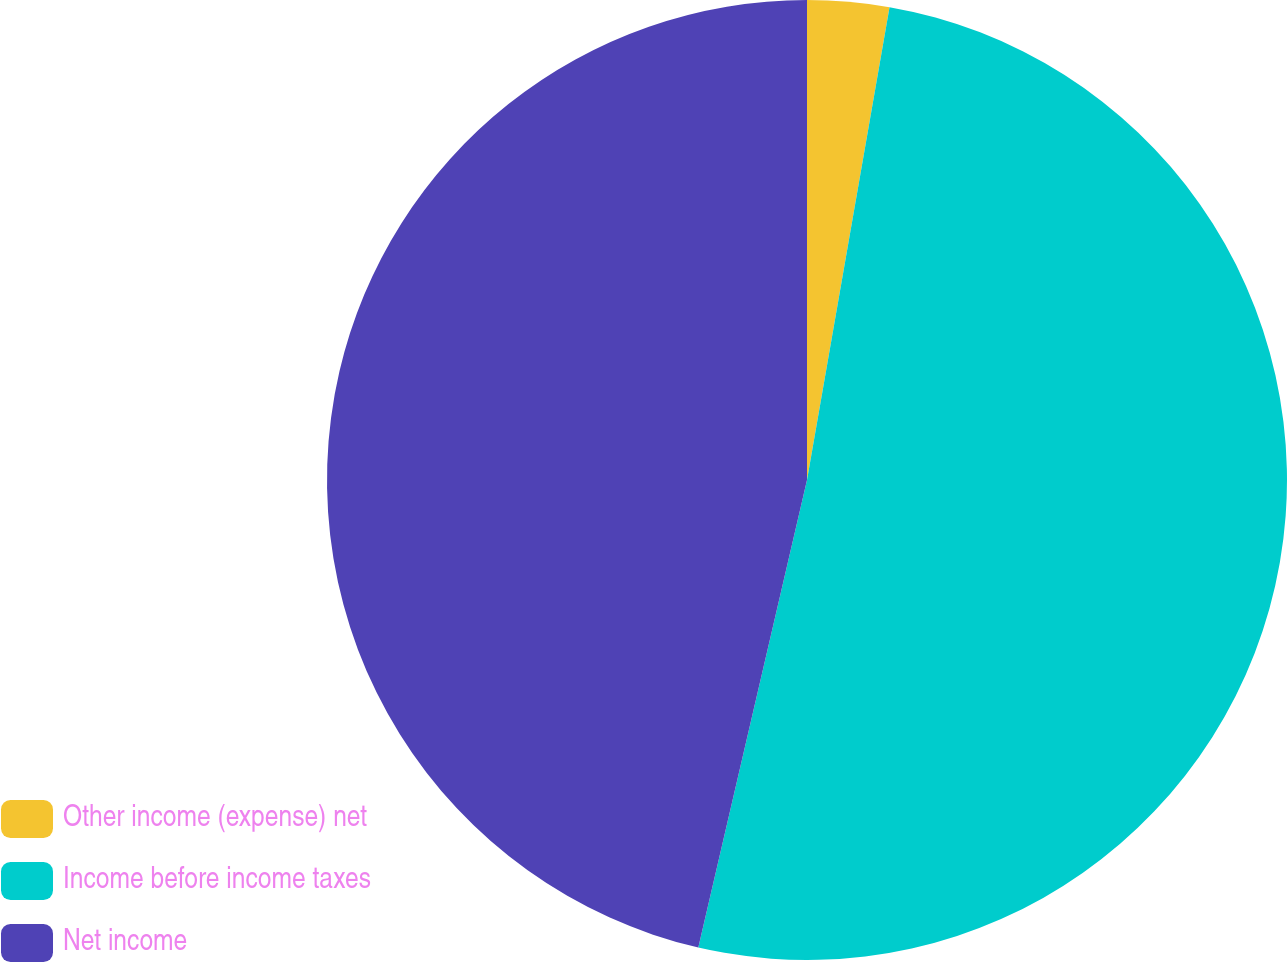Convert chart to OTSL. <chart><loc_0><loc_0><loc_500><loc_500><pie_chart><fcel>Other income (expense) net<fcel>Income before income taxes<fcel>Net income<nl><fcel>2.75%<fcel>50.88%<fcel>46.36%<nl></chart> 